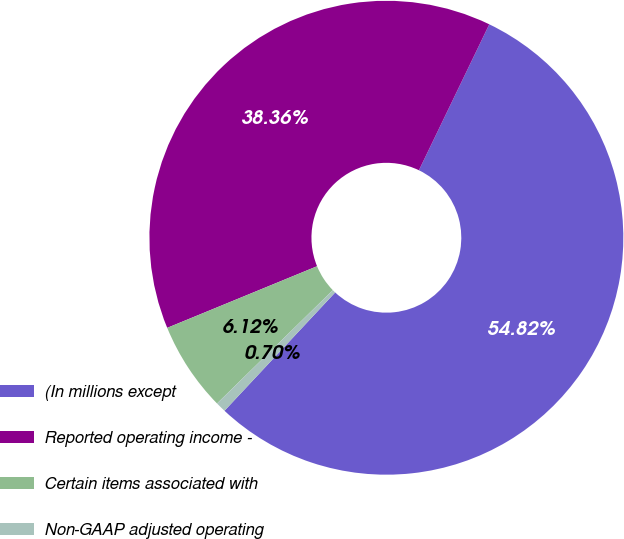<chart> <loc_0><loc_0><loc_500><loc_500><pie_chart><fcel>(In millions except<fcel>Reported operating income -<fcel>Certain items associated with<fcel>Non-GAAP adjusted operating<nl><fcel>54.82%<fcel>38.36%<fcel>6.12%<fcel>0.7%<nl></chart> 